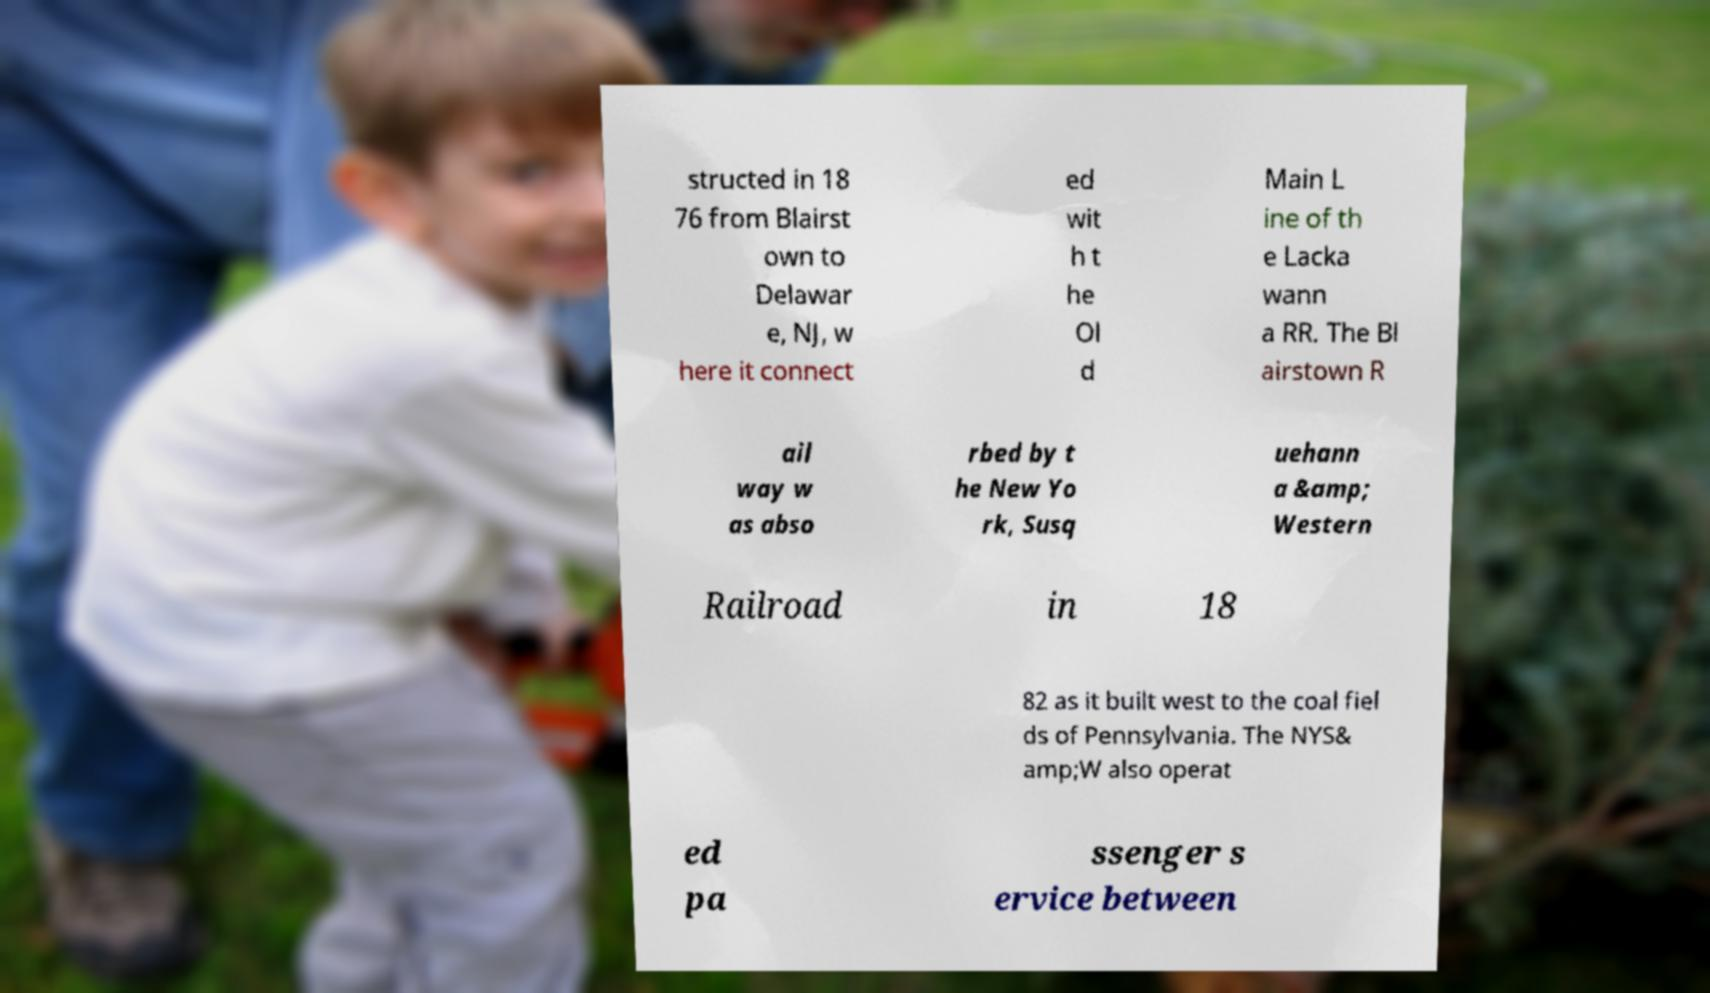Please read and relay the text visible in this image. What does it say? structed in 18 76 from Blairst own to Delawar e, NJ, w here it connect ed wit h t he Ol d Main L ine of th e Lacka wann a RR. The Bl airstown R ail way w as abso rbed by t he New Yo rk, Susq uehann a &amp; Western Railroad in 18 82 as it built west to the coal fiel ds of Pennsylvania. The NYS& amp;W also operat ed pa ssenger s ervice between 